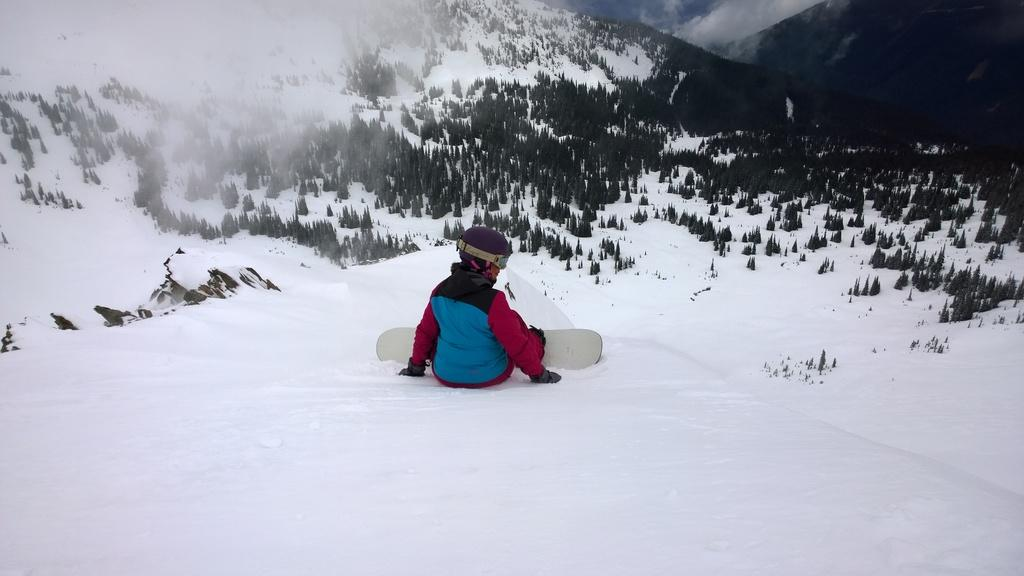What is the person in the image doing? The person is on a skateboard in the image. What surface is the skateboard on? The skateboard is on the snow in the image. What can be seen in the middle of the image? There are trees in the middle of the image. What is the terrain like at the top of the image? There is a hill at the top of the image. What is the brother's reaction to the person on the skateboard in the image? There is no brother present in the image, so it is not possible to determine their reaction. 